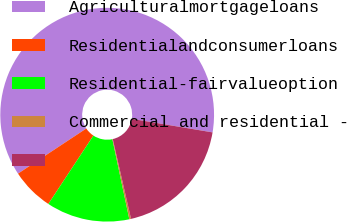Convert chart. <chart><loc_0><loc_0><loc_500><loc_500><pie_chart><fcel>Agriculturalmortgageloans<fcel>Residentialandconsumerloans<fcel>Residential-fairvalueoption<fcel>Commercial and residential -<fcel>Unnamed: 4<nl><fcel>61.95%<fcel>6.43%<fcel>12.6%<fcel>0.26%<fcel>18.77%<nl></chart> 